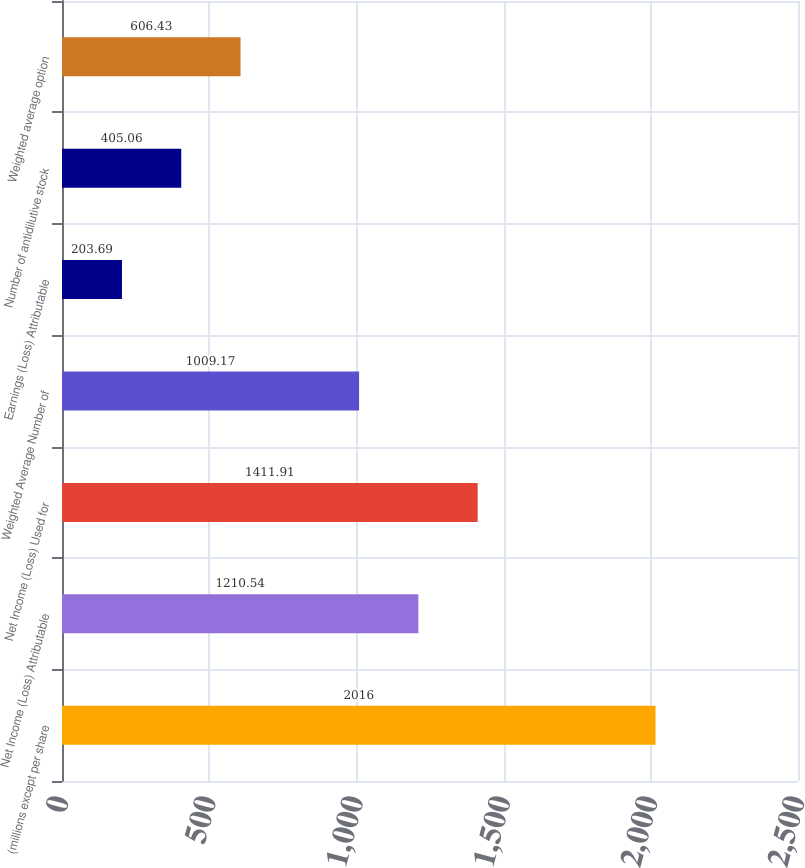<chart> <loc_0><loc_0><loc_500><loc_500><bar_chart><fcel>(millions except per share<fcel>Net Income (Loss) Attributable<fcel>Net Income (Loss) Used for<fcel>Weighted Average Number of<fcel>Earnings (Loss) Attributable<fcel>Number of antidilutive stock<fcel>Weighted average option<nl><fcel>2016<fcel>1210.54<fcel>1411.91<fcel>1009.17<fcel>203.69<fcel>405.06<fcel>606.43<nl></chart> 